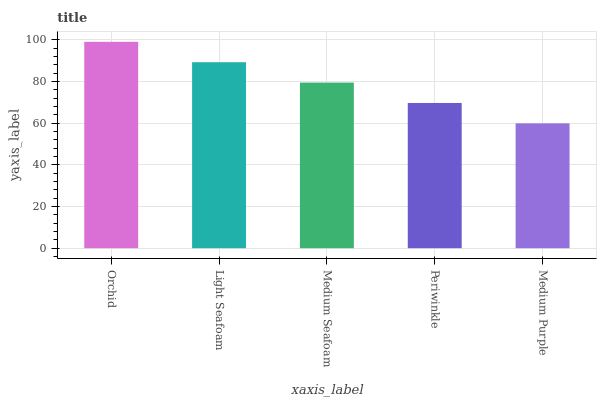Is Light Seafoam the minimum?
Answer yes or no. No. Is Light Seafoam the maximum?
Answer yes or no. No. Is Orchid greater than Light Seafoam?
Answer yes or no. Yes. Is Light Seafoam less than Orchid?
Answer yes or no. Yes. Is Light Seafoam greater than Orchid?
Answer yes or no. No. Is Orchid less than Light Seafoam?
Answer yes or no. No. Is Medium Seafoam the high median?
Answer yes or no. Yes. Is Medium Seafoam the low median?
Answer yes or no. Yes. Is Light Seafoam the high median?
Answer yes or no. No. Is Medium Purple the low median?
Answer yes or no. No. 